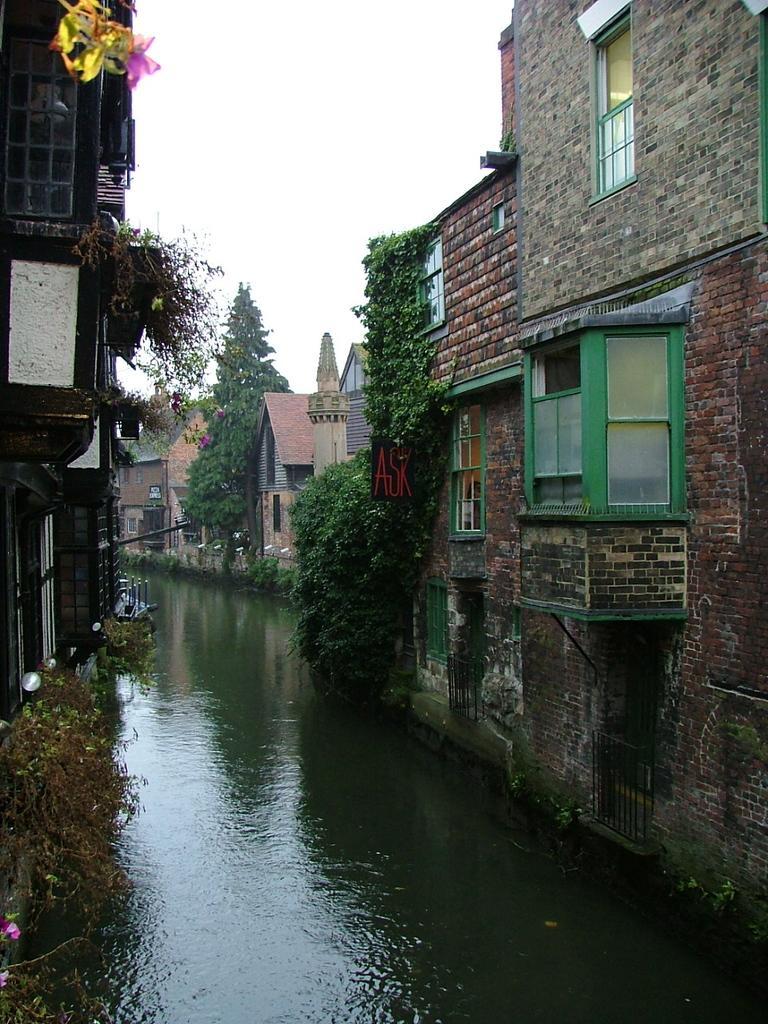Can you describe this image briefly? At the bottom of the picture, we see water and this might be a lake. On either side of that, there are many buildings and trees. At the top of the picture, we see the sky. 